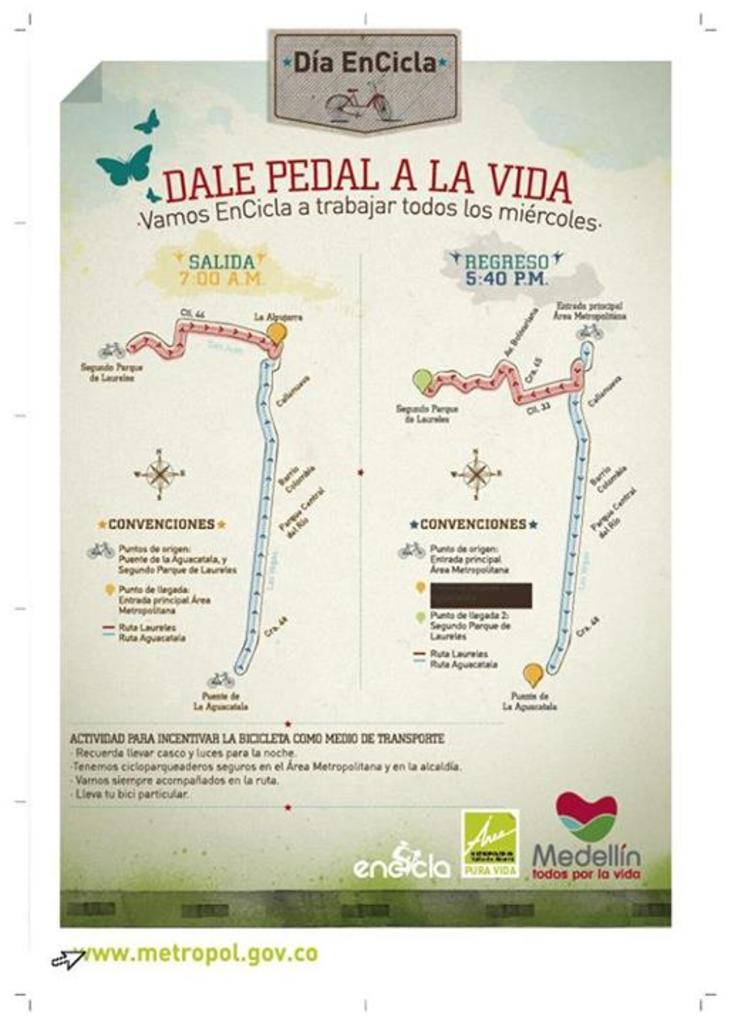<image>
Create a compact narrative representing the image presented. The article shown is named Dale Pedal A La Vida. 